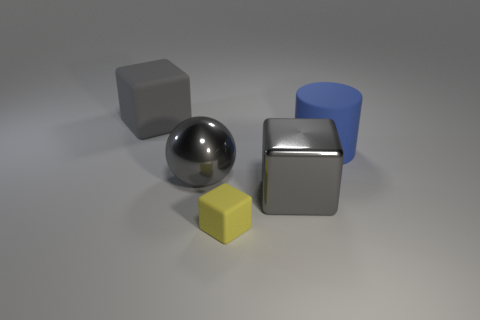There is a shiny thing on the left side of the yellow block; what is its shape?
Your answer should be compact. Sphere. What is the color of the matte cylinder?
Give a very brief answer. Blue. Does the gray ball have the same size as the gray block to the right of the large gray rubber thing?
Offer a terse response. Yes. What number of metal objects are big cubes or cylinders?
Your response must be concise. 1. Do the metal ball and the rubber cube to the left of the gray sphere have the same color?
Make the answer very short. Yes. What is the shape of the blue matte object?
Make the answer very short. Cylinder. What size is the gray metallic block behind the matte block that is right of the gray shiny object that is on the left side of the gray metal block?
Ensure brevity in your answer.  Large. What number of other objects are there of the same shape as the yellow matte object?
Offer a very short reply. 2. There is a large metallic thing on the right side of the yellow thing; is it the same shape as the small yellow rubber object that is left of the big metallic block?
Your answer should be compact. Yes. What number of spheres are gray objects or large blue rubber objects?
Provide a succinct answer. 1. 